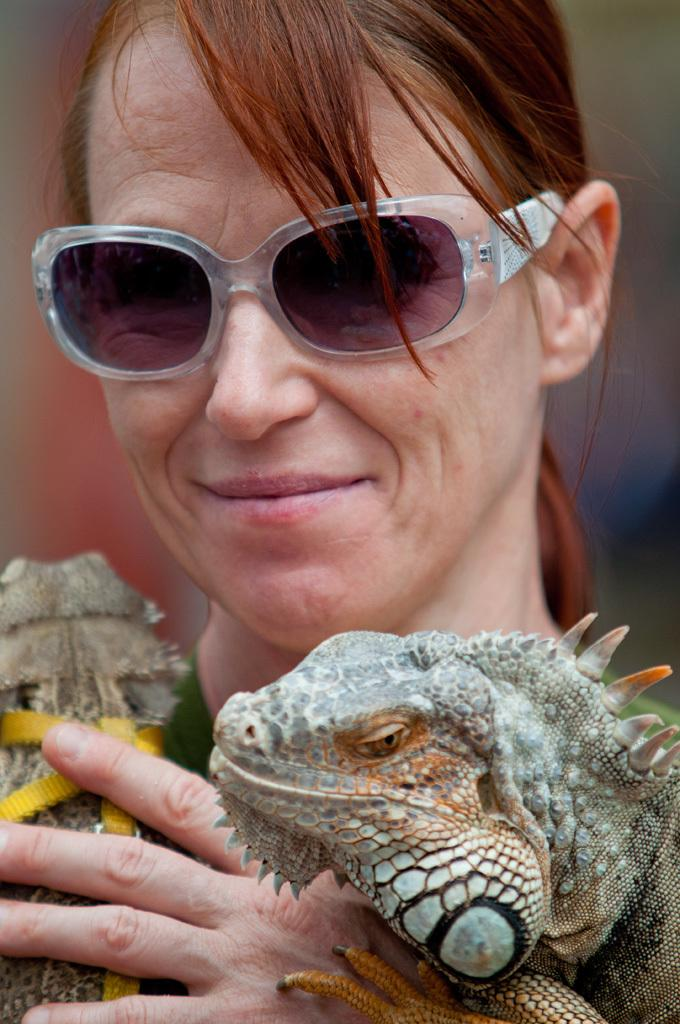What is the main subject of the image? There is a person in the image. What is the person wearing? The person is wearing goggles. What is the person holding in the image? The person is holding reptiles. Can you describe the reptiles? The reptiles are in brown and grey colors. What is the condition of the background in the image? The background of the image is blurred. What type of finger can be seen holding a piece of sleet in the image? There is no finger or sleet present in the image. 